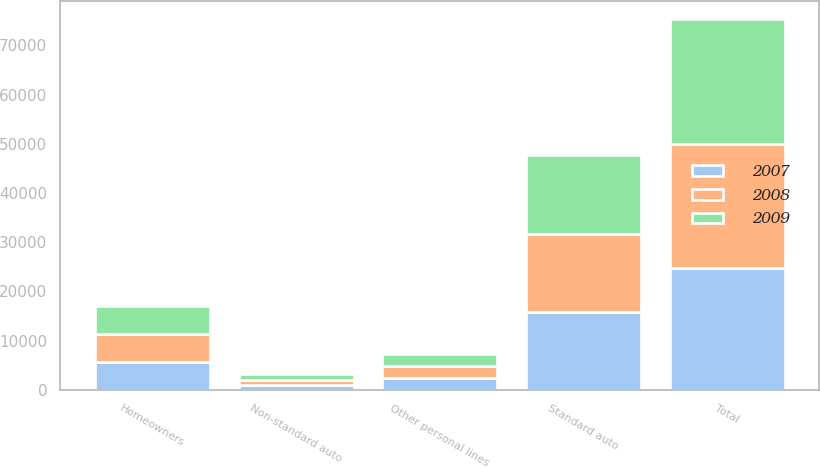<chart> <loc_0><loc_0><loc_500><loc_500><stacked_bar_chart><ecel><fcel>Standard auto<fcel>Non-standard auto<fcel>Homeowners<fcel>Other personal lines<fcel>Total<nl><fcel>2007<fcel>15735<fcel>939<fcel>5633<fcel>2402<fcel>24709<nl><fcel>2008<fcel>15957<fcel>1055<fcel>5758<fcel>2434<fcel>25204<nl><fcel>2009<fcel>15952<fcel>1232<fcel>5732<fcel>2426<fcel>25342<nl></chart> 